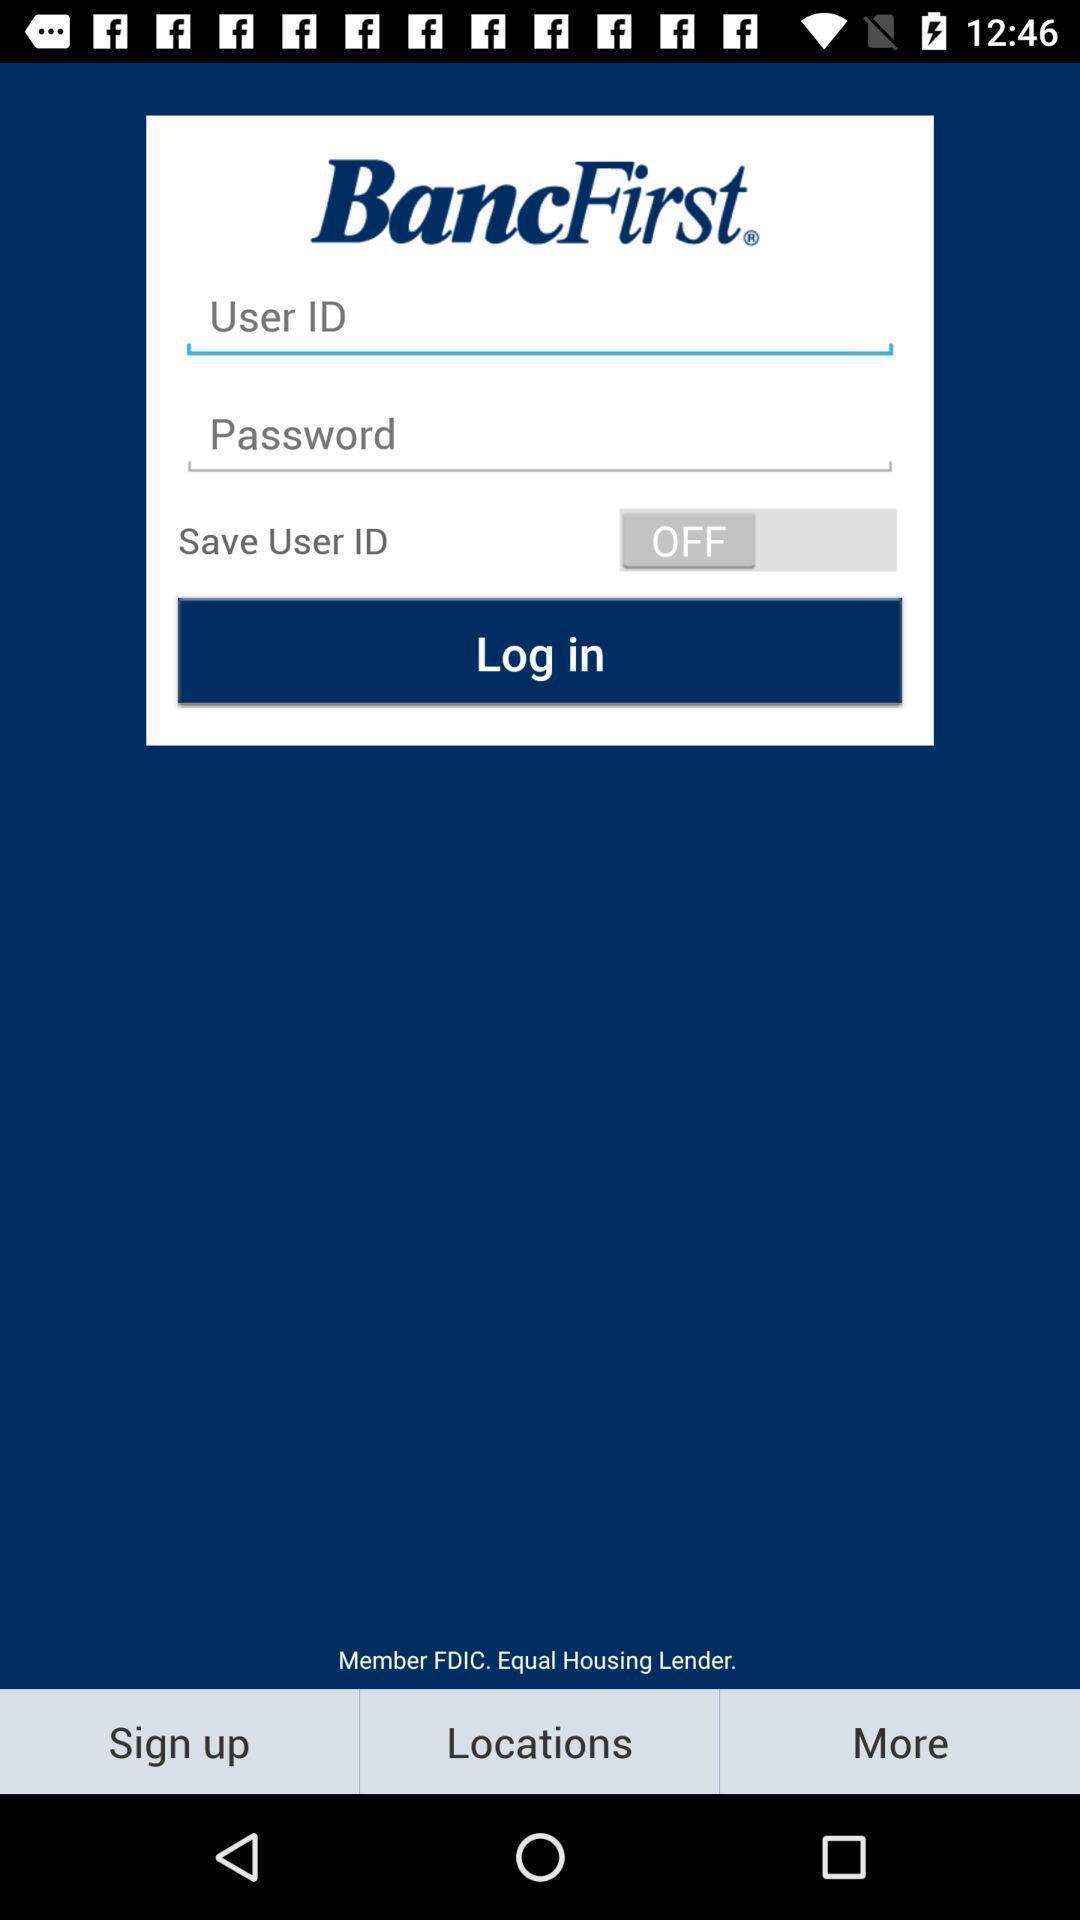Describe this image in words. Login page. 